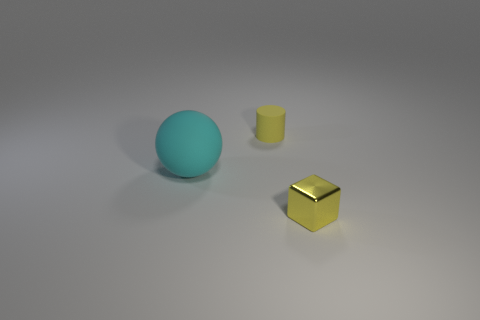Add 1 purple cylinders. How many objects exist? 4 Subtract all spheres. How many objects are left? 2 Subtract 0 purple cylinders. How many objects are left? 3 Subtract all shiny spheres. Subtract all big matte things. How many objects are left? 2 Add 2 tiny yellow things. How many tiny yellow things are left? 4 Add 1 big cyan matte things. How many big cyan matte things exist? 2 